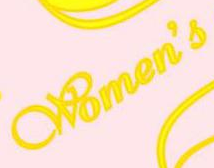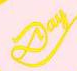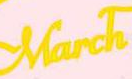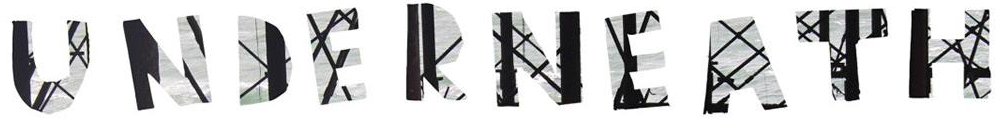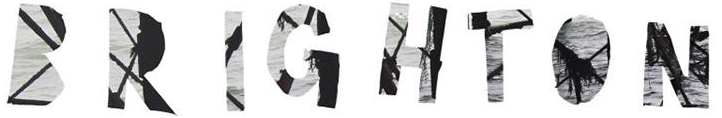Identify the words shown in these images in order, separated by a semicolon. Women's; Day; March; UNDERNEATH; BRIGHTON 